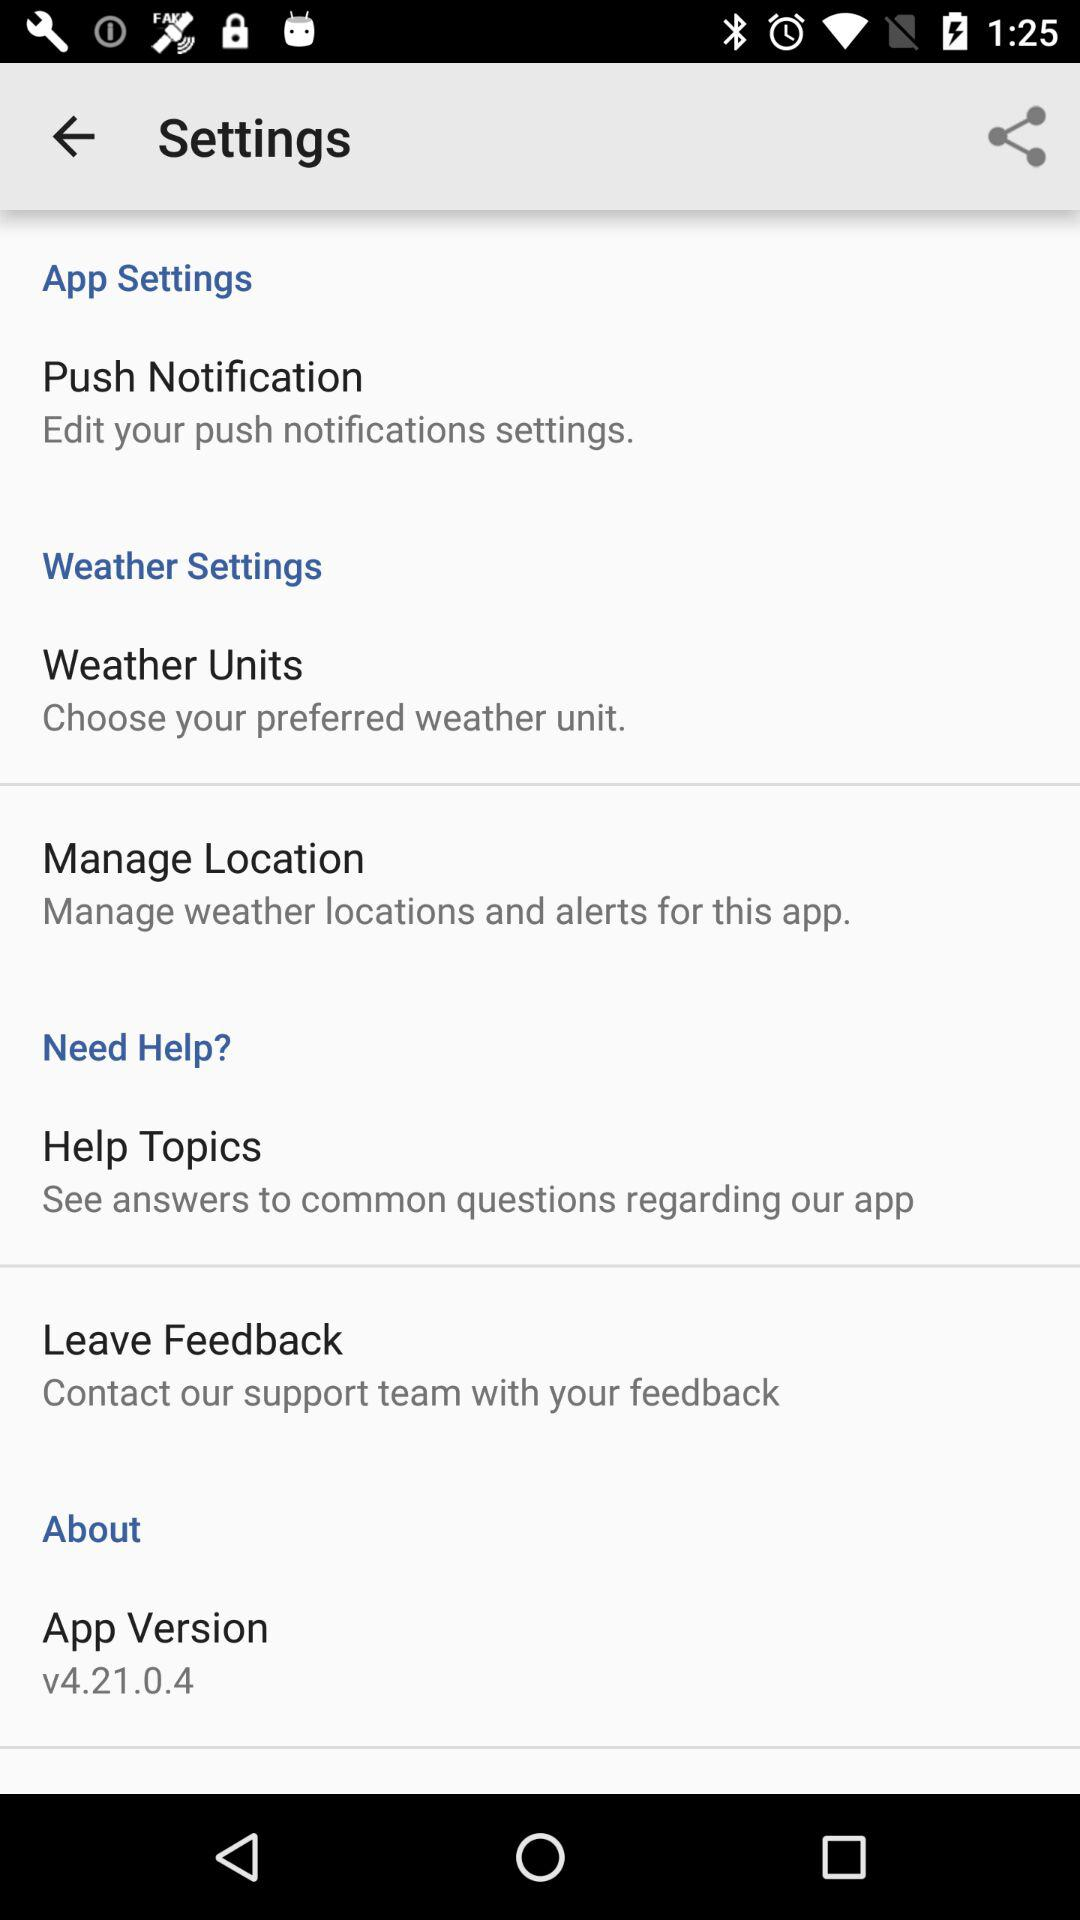What is the app version? The app version is v4.21.0.4. 